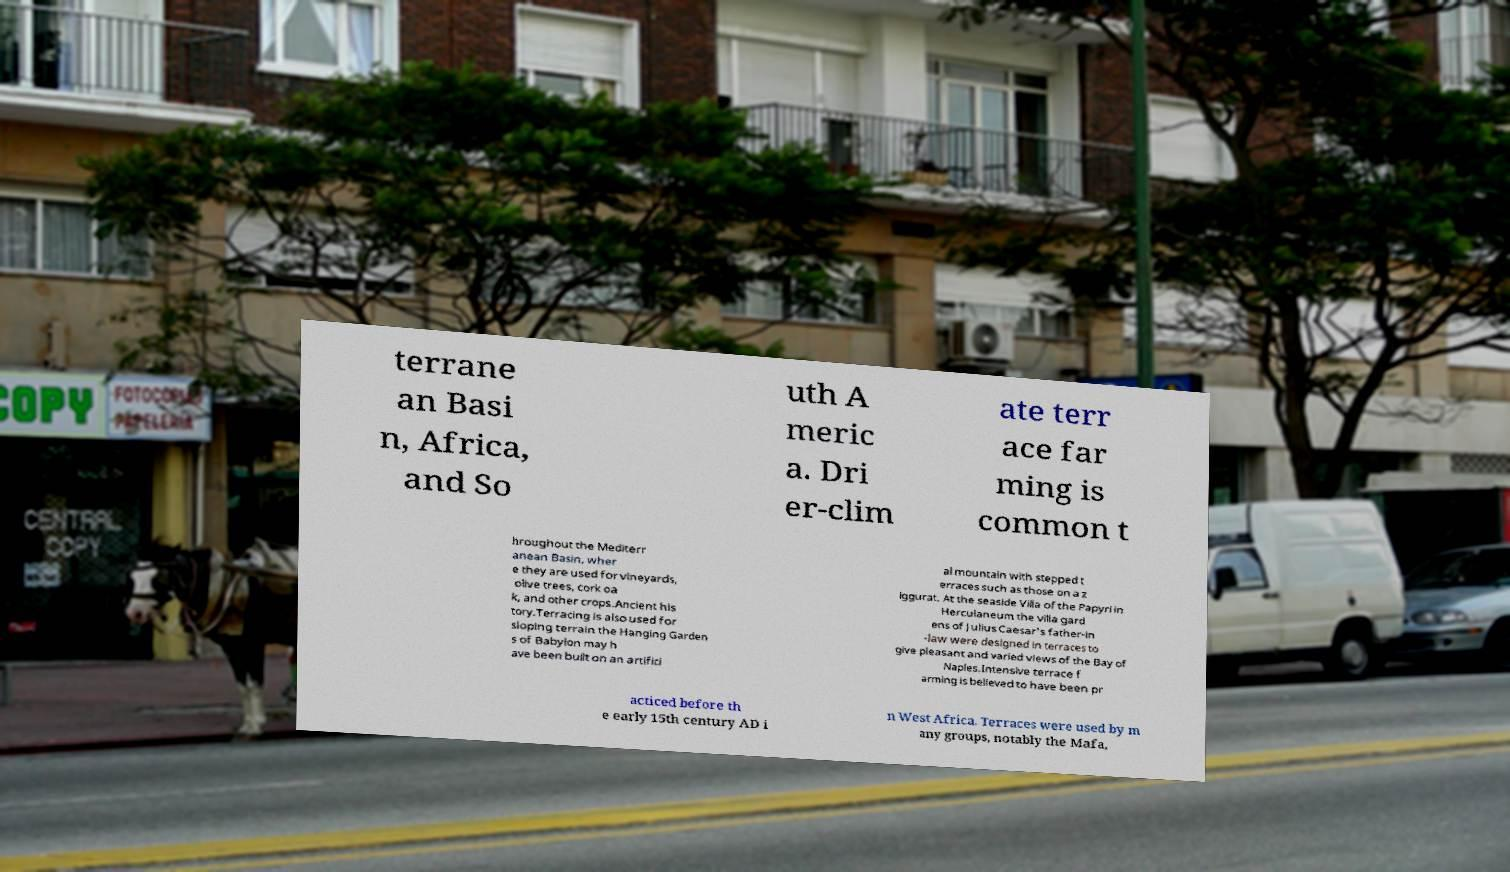Can you read and provide the text displayed in the image?This photo seems to have some interesting text. Can you extract and type it out for me? terrane an Basi n, Africa, and So uth A meric a. Dri er-clim ate terr ace far ming is common t hroughout the Mediterr anean Basin, wher e they are used for vineyards, olive trees, cork oa k, and other crops.Ancient his tory.Terracing is also used for sloping terrain the Hanging Garden s of Babylon may h ave been built on an artifici al mountain with stepped t erraces such as those on a z iggurat. At the seaside Villa of the Papyri in Herculaneum the villa gard ens of Julius Caesar's father-in -law were designed in terraces to give pleasant and varied views of the Bay of Naples.Intensive terrace f arming is believed to have been pr acticed before th e early 15th century AD i n West Africa. Terraces were used by m any groups, notably the Mafa, 